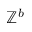Convert formula to latex. <formula><loc_0><loc_0><loc_500><loc_500>\mathbb { Z } ^ { b }</formula> 